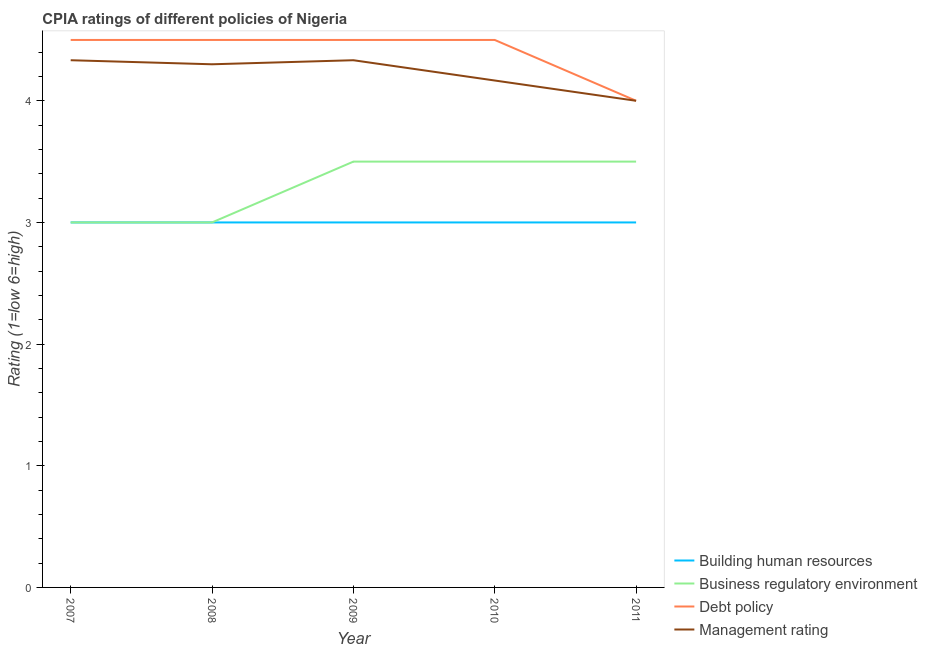How many different coloured lines are there?
Your answer should be very brief. 4. What is the cpia rating of building human resources in 2009?
Ensure brevity in your answer.  3. Across all years, what is the maximum cpia rating of business regulatory environment?
Provide a succinct answer. 3.5. In which year was the cpia rating of debt policy maximum?
Make the answer very short. 2007. What is the average cpia rating of building human resources per year?
Give a very brief answer. 3. In the year 2007, what is the difference between the cpia rating of management and cpia rating of business regulatory environment?
Make the answer very short. 1.33. In how many years, is the cpia rating of debt policy greater than 3.6?
Your answer should be very brief. 5. What is the difference between the highest and the second highest cpia rating of building human resources?
Keep it short and to the point. 0. What is the difference between the highest and the lowest cpia rating of debt policy?
Ensure brevity in your answer.  0.5. In how many years, is the cpia rating of debt policy greater than the average cpia rating of debt policy taken over all years?
Offer a terse response. 4. Is the sum of the cpia rating of management in 2007 and 2009 greater than the maximum cpia rating of business regulatory environment across all years?
Provide a short and direct response. Yes. Is it the case that in every year, the sum of the cpia rating of business regulatory environment and cpia rating of debt policy is greater than the sum of cpia rating of management and cpia rating of building human resources?
Your answer should be compact. No. Is the cpia rating of business regulatory environment strictly greater than the cpia rating of building human resources over the years?
Offer a terse response. No. What is the difference between two consecutive major ticks on the Y-axis?
Offer a very short reply. 1. Are the values on the major ticks of Y-axis written in scientific E-notation?
Your response must be concise. No. Does the graph contain any zero values?
Your response must be concise. No. Where does the legend appear in the graph?
Your answer should be compact. Bottom right. What is the title of the graph?
Make the answer very short. CPIA ratings of different policies of Nigeria. What is the label or title of the Y-axis?
Your answer should be compact. Rating (1=low 6=high). What is the Rating (1=low 6=high) in Debt policy in 2007?
Offer a very short reply. 4.5. What is the Rating (1=low 6=high) in Management rating in 2007?
Your answer should be compact. 4.33. What is the Rating (1=low 6=high) of Building human resources in 2008?
Your answer should be very brief. 3. What is the Rating (1=low 6=high) in Business regulatory environment in 2008?
Provide a short and direct response. 3. What is the Rating (1=low 6=high) of Business regulatory environment in 2009?
Ensure brevity in your answer.  3.5. What is the Rating (1=low 6=high) of Debt policy in 2009?
Offer a terse response. 4.5. What is the Rating (1=low 6=high) of Management rating in 2009?
Provide a short and direct response. 4.33. What is the Rating (1=low 6=high) of Debt policy in 2010?
Keep it short and to the point. 4.5. What is the Rating (1=low 6=high) in Management rating in 2010?
Give a very brief answer. 4.17. Across all years, what is the maximum Rating (1=low 6=high) of Building human resources?
Keep it short and to the point. 3. Across all years, what is the maximum Rating (1=low 6=high) of Business regulatory environment?
Ensure brevity in your answer.  3.5. Across all years, what is the maximum Rating (1=low 6=high) of Management rating?
Provide a succinct answer. 4.33. Across all years, what is the minimum Rating (1=low 6=high) of Building human resources?
Your answer should be very brief. 3. Across all years, what is the minimum Rating (1=low 6=high) in Business regulatory environment?
Your answer should be compact. 3. What is the total Rating (1=low 6=high) in Building human resources in the graph?
Your answer should be very brief. 15. What is the total Rating (1=low 6=high) of Debt policy in the graph?
Keep it short and to the point. 22. What is the total Rating (1=low 6=high) in Management rating in the graph?
Provide a succinct answer. 21.13. What is the difference between the Rating (1=low 6=high) in Business regulatory environment in 2007 and that in 2008?
Ensure brevity in your answer.  0. What is the difference between the Rating (1=low 6=high) of Management rating in 2007 and that in 2008?
Give a very brief answer. 0.03. What is the difference between the Rating (1=low 6=high) of Building human resources in 2007 and that in 2009?
Your answer should be compact. 0. What is the difference between the Rating (1=low 6=high) in Business regulatory environment in 2007 and that in 2009?
Offer a terse response. -0.5. What is the difference between the Rating (1=low 6=high) in Debt policy in 2007 and that in 2009?
Give a very brief answer. 0. What is the difference between the Rating (1=low 6=high) of Management rating in 2007 and that in 2009?
Your answer should be compact. 0. What is the difference between the Rating (1=low 6=high) of Debt policy in 2007 and that in 2010?
Ensure brevity in your answer.  0. What is the difference between the Rating (1=low 6=high) of Building human resources in 2007 and that in 2011?
Offer a terse response. 0. What is the difference between the Rating (1=low 6=high) in Management rating in 2007 and that in 2011?
Make the answer very short. 0.33. What is the difference between the Rating (1=low 6=high) of Debt policy in 2008 and that in 2009?
Your answer should be very brief. 0. What is the difference between the Rating (1=low 6=high) in Management rating in 2008 and that in 2009?
Your answer should be compact. -0.03. What is the difference between the Rating (1=low 6=high) of Debt policy in 2008 and that in 2010?
Ensure brevity in your answer.  0. What is the difference between the Rating (1=low 6=high) of Management rating in 2008 and that in 2010?
Give a very brief answer. 0.13. What is the difference between the Rating (1=low 6=high) of Building human resources in 2008 and that in 2011?
Your response must be concise. 0. What is the difference between the Rating (1=low 6=high) in Business regulatory environment in 2008 and that in 2011?
Provide a succinct answer. -0.5. What is the difference between the Rating (1=low 6=high) of Debt policy in 2009 and that in 2010?
Keep it short and to the point. 0. What is the difference between the Rating (1=low 6=high) of Building human resources in 2009 and that in 2011?
Make the answer very short. 0. What is the difference between the Rating (1=low 6=high) of Debt policy in 2009 and that in 2011?
Your response must be concise. 0.5. What is the difference between the Rating (1=low 6=high) of Business regulatory environment in 2010 and that in 2011?
Provide a short and direct response. 0. What is the difference between the Rating (1=low 6=high) in Management rating in 2010 and that in 2011?
Offer a very short reply. 0.17. What is the difference between the Rating (1=low 6=high) in Business regulatory environment in 2007 and the Rating (1=low 6=high) in Management rating in 2008?
Provide a short and direct response. -1.3. What is the difference between the Rating (1=low 6=high) in Building human resources in 2007 and the Rating (1=low 6=high) in Business regulatory environment in 2009?
Your answer should be very brief. -0.5. What is the difference between the Rating (1=low 6=high) of Building human resources in 2007 and the Rating (1=low 6=high) of Debt policy in 2009?
Offer a terse response. -1.5. What is the difference between the Rating (1=low 6=high) of Building human resources in 2007 and the Rating (1=low 6=high) of Management rating in 2009?
Provide a succinct answer. -1.33. What is the difference between the Rating (1=low 6=high) of Business regulatory environment in 2007 and the Rating (1=low 6=high) of Management rating in 2009?
Provide a succinct answer. -1.33. What is the difference between the Rating (1=low 6=high) of Building human resources in 2007 and the Rating (1=low 6=high) of Business regulatory environment in 2010?
Provide a succinct answer. -0.5. What is the difference between the Rating (1=low 6=high) of Building human resources in 2007 and the Rating (1=low 6=high) of Debt policy in 2010?
Provide a short and direct response. -1.5. What is the difference between the Rating (1=low 6=high) of Building human resources in 2007 and the Rating (1=low 6=high) of Management rating in 2010?
Ensure brevity in your answer.  -1.17. What is the difference between the Rating (1=low 6=high) of Business regulatory environment in 2007 and the Rating (1=low 6=high) of Debt policy in 2010?
Offer a very short reply. -1.5. What is the difference between the Rating (1=low 6=high) of Business regulatory environment in 2007 and the Rating (1=low 6=high) of Management rating in 2010?
Offer a very short reply. -1.17. What is the difference between the Rating (1=low 6=high) in Debt policy in 2007 and the Rating (1=low 6=high) in Management rating in 2010?
Make the answer very short. 0.33. What is the difference between the Rating (1=low 6=high) in Building human resources in 2007 and the Rating (1=low 6=high) in Debt policy in 2011?
Your response must be concise. -1. What is the difference between the Rating (1=low 6=high) in Business regulatory environment in 2007 and the Rating (1=low 6=high) in Debt policy in 2011?
Give a very brief answer. -1. What is the difference between the Rating (1=low 6=high) in Business regulatory environment in 2007 and the Rating (1=low 6=high) in Management rating in 2011?
Ensure brevity in your answer.  -1. What is the difference between the Rating (1=low 6=high) of Debt policy in 2007 and the Rating (1=low 6=high) of Management rating in 2011?
Ensure brevity in your answer.  0.5. What is the difference between the Rating (1=low 6=high) in Building human resources in 2008 and the Rating (1=low 6=high) in Business regulatory environment in 2009?
Provide a succinct answer. -0.5. What is the difference between the Rating (1=low 6=high) in Building human resources in 2008 and the Rating (1=low 6=high) in Debt policy in 2009?
Give a very brief answer. -1.5. What is the difference between the Rating (1=low 6=high) in Building human resources in 2008 and the Rating (1=low 6=high) in Management rating in 2009?
Your answer should be very brief. -1.33. What is the difference between the Rating (1=low 6=high) of Business regulatory environment in 2008 and the Rating (1=low 6=high) of Management rating in 2009?
Keep it short and to the point. -1.33. What is the difference between the Rating (1=low 6=high) in Debt policy in 2008 and the Rating (1=low 6=high) in Management rating in 2009?
Give a very brief answer. 0.17. What is the difference between the Rating (1=low 6=high) of Building human resources in 2008 and the Rating (1=low 6=high) of Business regulatory environment in 2010?
Provide a short and direct response. -0.5. What is the difference between the Rating (1=low 6=high) in Building human resources in 2008 and the Rating (1=low 6=high) in Debt policy in 2010?
Keep it short and to the point. -1.5. What is the difference between the Rating (1=low 6=high) in Building human resources in 2008 and the Rating (1=low 6=high) in Management rating in 2010?
Your answer should be very brief. -1.17. What is the difference between the Rating (1=low 6=high) in Business regulatory environment in 2008 and the Rating (1=low 6=high) in Management rating in 2010?
Provide a succinct answer. -1.17. What is the difference between the Rating (1=low 6=high) in Building human resources in 2008 and the Rating (1=low 6=high) in Debt policy in 2011?
Your answer should be compact. -1. What is the difference between the Rating (1=low 6=high) in Business regulatory environment in 2008 and the Rating (1=low 6=high) in Debt policy in 2011?
Make the answer very short. -1. What is the difference between the Rating (1=low 6=high) in Business regulatory environment in 2008 and the Rating (1=low 6=high) in Management rating in 2011?
Provide a short and direct response. -1. What is the difference between the Rating (1=low 6=high) in Debt policy in 2008 and the Rating (1=low 6=high) in Management rating in 2011?
Offer a very short reply. 0.5. What is the difference between the Rating (1=low 6=high) in Building human resources in 2009 and the Rating (1=low 6=high) in Business regulatory environment in 2010?
Give a very brief answer. -0.5. What is the difference between the Rating (1=low 6=high) in Building human resources in 2009 and the Rating (1=low 6=high) in Debt policy in 2010?
Offer a terse response. -1.5. What is the difference between the Rating (1=low 6=high) of Building human resources in 2009 and the Rating (1=low 6=high) of Management rating in 2010?
Provide a short and direct response. -1.17. What is the difference between the Rating (1=low 6=high) of Business regulatory environment in 2009 and the Rating (1=low 6=high) of Debt policy in 2010?
Your answer should be compact. -1. What is the difference between the Rating (1=low 6=high) of Business regulatory environment in 2009 and the Rating (1=low 6=high) of Management rating in 2010?
Make the answer very short. -0.67. What is the difference between the Rating (1=low 6=high) in Building human resources in 2009 and the Rating (1=low 6=high) in Business regulatory environment in 2011?
Give a very brief answer. -0.5. What is the difference between the Rating (1=low 6=high) in Building human resources in 2009 and the Rating (1=low 6=high) in Debt policy in 2011?
Your answer should be very brief. -1. What is the difference between the Rating (1=low 6=high) in Business regulatory environment in 2009 and the Rating (1=low 6=high) in Management rating in 2011?
Keep it short and to the point. -0.5. What is the difference between the Rating (1=low 6=high) in Building human resources in 2010 and the Rating (1=low 6=high) in Business regulatory environment in 2011?
Your response must be concise. -0.5. What is the difference between the Rating (1=low 6=high) in Building human resources in 2010 and the Rating (1=low 6=high) in Management rating in 2011?
Offer a very short reply. -1. What is the difference between the Rating (1=low 6=high) in Debt policy in 2010 and the Rating (1=low 6=high) in Management rating in 2011?
Offer a very short reply. 0.5. What is the average Rating (1=low 6=high) in Building human resources per year?
Offer a terse response. 3. What is the average Rating (1=low 6=high) of Management rating per year?
Keep it short and to the point. 4.23. In the year 2007, what is the difference between the Rating (1=low 6=high) in Building human resources and Rating (1=low 6=high) in Business regulatory environment?
Give a very brief answer. 0. In the year 2007, what is the difference between the Rating (1=low 6=high) in Building human resources and Rating (1=low 6=high) in Management rating?
Provide a succinct answer. -1.33. In the year 2007, what is the difference between the Rating (1=low 6=high) of Business regulatory environment and Rating (1=low 6=high) of Management rating?
Give a very brief answer. -1.33. In the year 2008, what is the difference between the Rating (1=low 6=high) of Building human resources and Rating (1=low 6=high) of Business regulatory environment?
Your answer should be very brief. 0. In the year 2008, what is the difference between the Rating (1=low 6=high) in Building human resources and Rating (1=low 6=high) in Management rating?
Keep it short and to the point. -1.3. In the year 2008, what is the difference between the Rating (1=low 6=high) of Business regulatory environment and Rating (1=low 6=high) of Debt policy?
Your answer should be very brief. -1.5. In the year 2008, what is the difference between the Rating (1=low 6=high) in Debt policy and Rating (1=low 6=high) in Management rating?
Make the answer very short. 0.2. In the year 2009, what is the difference between the Rating (1=low 6=high) in Building human resources and Rating (1=low 6=high) in Debt policy?
Your response must be concise. -1.5. In the year 2009, what is the difference between the Rating (1=low 6=high) in Building human resources and Rating (1=low 6=high) in Management rating?
Provide a short and direct response. -1.33. In the year 2009, what is the difference between the Rating (1=low 6=high) in Business regulatory environment and Rating (1=low 6=high) in Debt policy?
Provide a short and direct response. -1. In the year 2009, what is the difference between the Rating (1=low 6=high) of Debt policy and Rating (1=low 6=high) of Management rating?
Give a very brief answer. 0.17. In the year 2010, what is the difference between the Rating (1=low 6=high) of Building human resources and Rating (1=low 6=high) of Management rating?
Provide a short and direct response. -1.17. In the year 2011, what is the difference between the Rating (1=low 6=high) of Building human resources and Rating (1=low 6=high) of Business regulatory environment?
Offer a very short reply. -0.5. In the year 2011, what is the difference between the Rating (1=low 6=high) of Building human resources and Rating (1=low 6=high) of Debt policy?
Your response must be concise. -1. In the year 2011, what is the difference between the Rating (1=low 6=high) in Business regulatory environment and Rating (1=low 6=high) in Debt policy?
Offer a very short reply. -0.5. In the year 2011, what is the difference between the Rating (1=low 6=high) of Debt policy and Rating (1=low 6=high) of Management rating?
Your answer should be very brief. 0. What is the ratio of the Rating (1=low 6=high) in Building human resources in 2007 to that in 2008?
Offer a terse response. 1. What is the ratio of the Rating (1=low 6=high) of Business regulatory environment in 2007 to that in 2009?
Your response must be concise. 0.86. What is the ratio of the Rating (1=low 6=high) in Debt policy in 2007 to that in 2009?
Your answer should be very brief. 1. What is the ratio of the Rating (1=low 6=high) in Debt policy in 2007 to that in 2010?
Ensure brevity in your answer.  1. What is the ratio of the Rating (1=low 6=high) in Management rating in 2007 to that in 2010?
Make the answer very short. 1.04. What is the ratio of the Rating (1=low 6=high) of Building human resources in 2007 to that in 2011?
Provide a succinct answer. 1. What is the ratio of the Rating (1=low 6=high) of Debt policy in 2007 to that in 2011?
Give a very brief answer. 1.12. What is the ratio of the Rating (1=low 6=high) of Management rating in 2007 to that in 2011?
Your response must be concise. 1.08. What is the ratio of the Rating (1=low 6=high) in Building human resources in 2008 to that in 2009?
Your answer should be compact. 1. What is the ratio of the Rating (1=low 6=high) of Management rating in 2008 to that in 2009?
Ensure brevity in your answer.  0.99. What is the ratio of the Rating (1=low 6=high) in Debt policy in 2008 to that in 2010?
Your answer should be compact. 1. What is the ratio of the Rating (1=low 6=high) in Management rating in 2008 to that in 2010?
Ensure brevity in your answer.  1.03. What is the ratio of the Rating (1=low 6=high) in Building human resources in 2008 to that in 2011?
Provide a short and direct response. 1. What is the ratio of the Rating (1=low 6=high) in Debt policy in 2008 to that in 2011?
Give a very brief answer. 1.12. What is the ratio of the Rating (1=low 6=high) of Management rating in 2008 to that in 2011?
Make the answer very short. 1.07. What is the ratio of the Rating (1=low 6=high) of Building human resources in 2009 to that in 2010?
Your response must be concise. 1. What is the ratio of the Rating (1=low 6=high) of Business regulatory environment in 2009 to that in 2010?
Offer a terse response. 1. What is the ratio of the Rating (1=low 6=high) in Debt policy in 2009 to that in 2010?
Your answer should be very brief. 1. What is the ratio of the Rating (1=low 6=high) of Management rating in 2009 to that in 2010?
Your answer should be compact. 1.04. What is the ratio of the Rating (1=low 6=high) of Business regulatory environment in 2009 to that in 2011?
Give a very brief answer. 1. What is the ratio of the Rating (1=low 6=high) in Management rating in 2009 to that in 2011?
Your answer should be very brief. 1.08. What is the ratio of the Rating (1=low 6=high) in Management rating in 2010 to that in 2011?
Your answer should be very brief. 1.04. What is the difference between the highest and the second highest Rating (1=low 6=high) in Business regulatory environment?
Ensure brevity in your answer.  0. What is the difference between the highest and the lowest Rating (1=low 6=high) of Building human resources?
Your answer should be very brief. 0. What is the difference between the highest and the lowest Rating (1=low 6=high) of Management rating?
Provide a succinct answer. 0.33. 